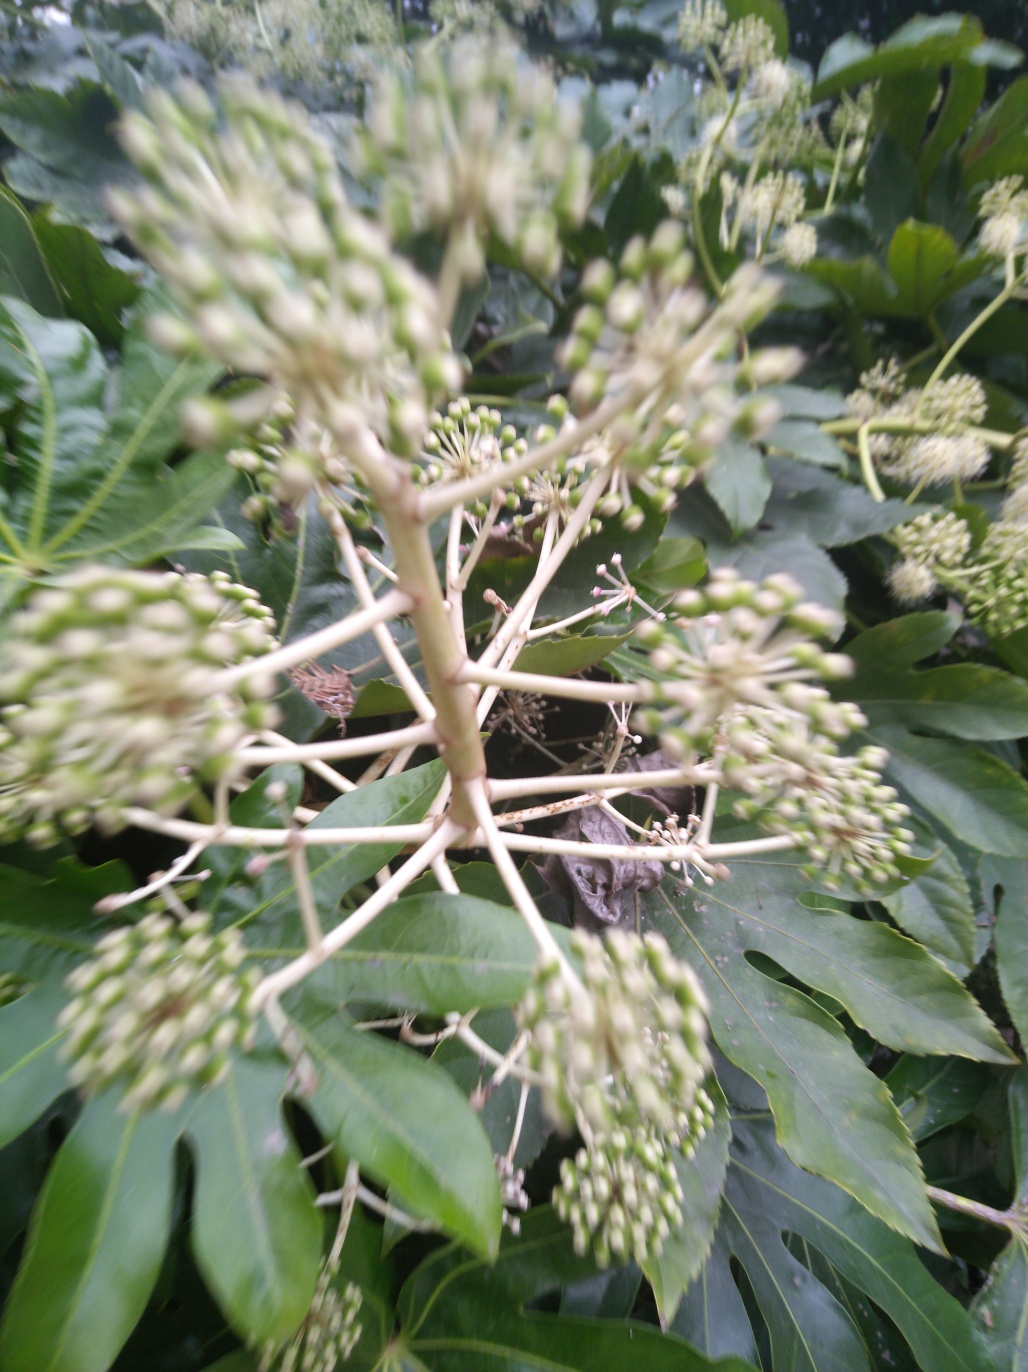How might motion blur affect the perception of this image if it were more pronounced? If the motion blur were more pronounced, it could add a dynamic quality to the image, emphasizing movement. However, it would also further obscure the details of the plant, potentially making the image less useful for identifying the species or appreciating the intricacies of its structure. 